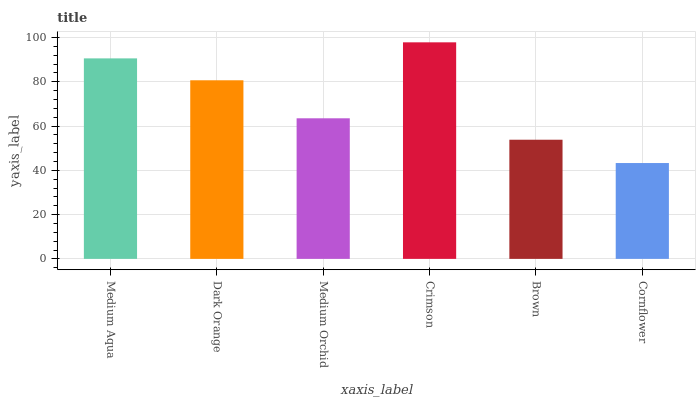Is Cornflower the minimum?
Answer yes or no. Yes. Is Crimson the maximum?
Answer yes or no. Yes. Is Dark Orange the minimum?
Answer yes or no. No. Is Dark Orange the maximum?
Answer yes or no. No. Is Medium Aqua greater than Dark Orange?
Answer yes or no. Yes. Is Dark Orange less than Medium Aqua?
Answer yes or no. Yes. Is Dark Orange greater than Medium Aqua?
Answer yes or no. No. Is Medium Aqua less than Dark Orange?
Answer yes or no. No. Is Dark Orange the high median?
Answer yes or no. Yes. Is Medium Orchid the low median?
Answer yes or no. Yes. Is Medium Orchid the high median?
Answer yes or no. No. Is Brown the low median?
Answer yes or no. No. 